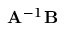<formula> <loc_0><loc_0><loc_500><loc_500>A ^ { - 1 } B</formula> 